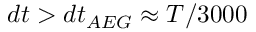Convert formula to latex. <formula><loc_0><loc_0><loc_500><loc_500>d t > d t _ { A E G } \approx T / 3 0 0 0</formula> 